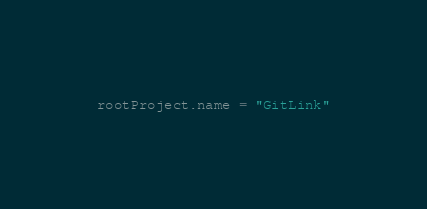<code> <loc_0><loc_0><loc_500><loc_500><_Kotlin_>rootProject.name = "GitLink"
</code> 